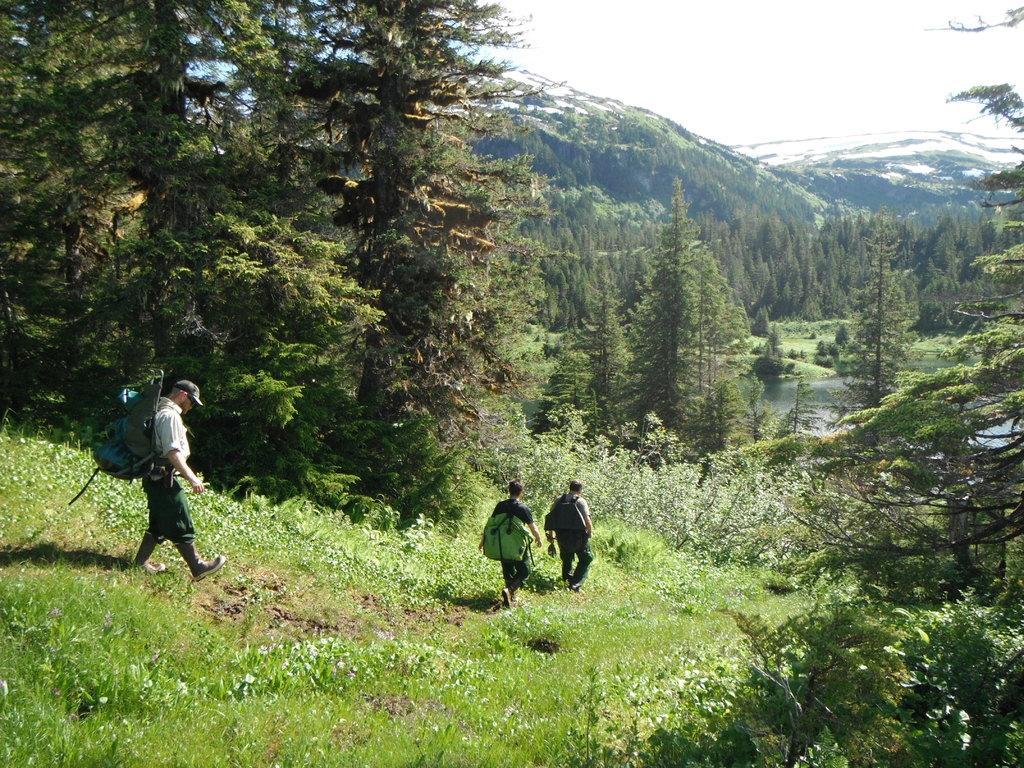Describe this image in one or two sentences. In this image we can see few persons are walking on the ground and all of them are carrying bags on their shoulders and we can see plants with flowers, grass and trees. In the background we can see water, trees, hills and clouds in the sky. 